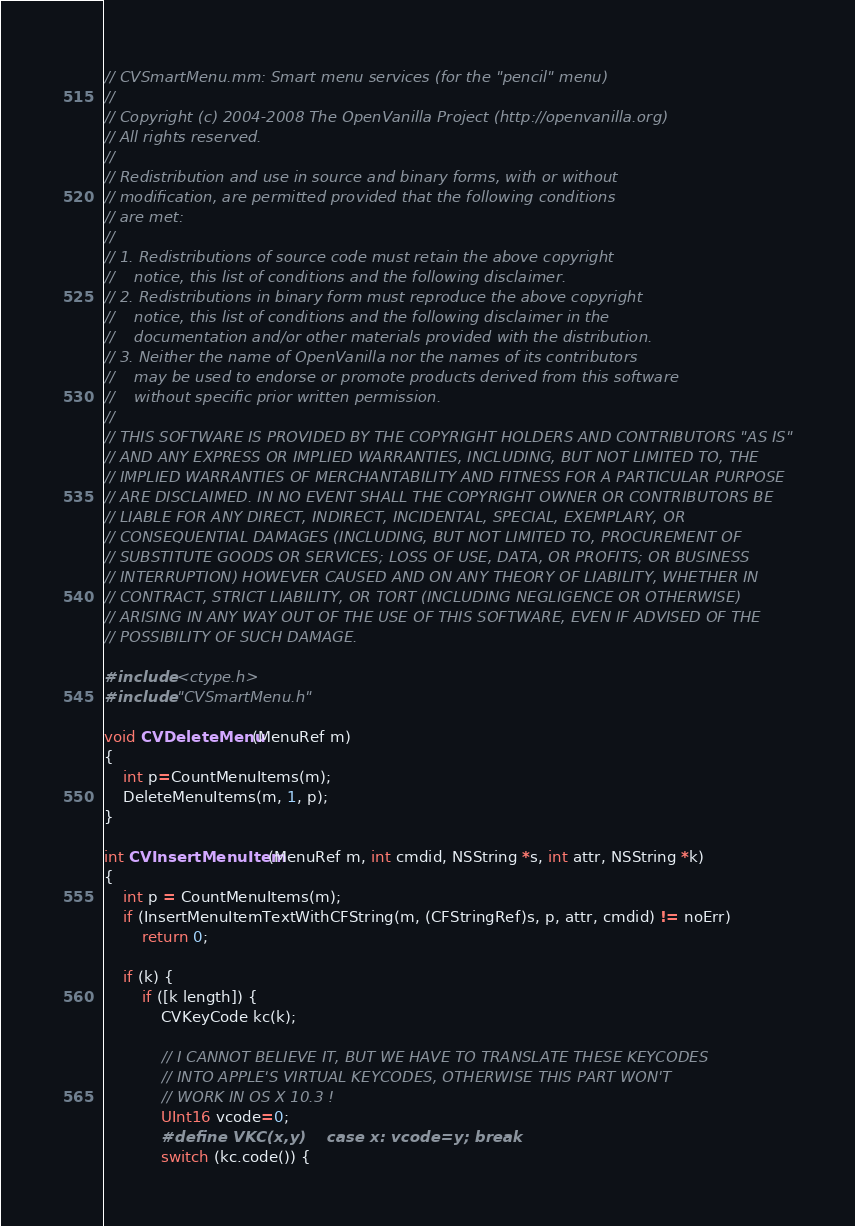Convert code to text. <code><loc_0><loc_0><loc_500><loc_500><_ObjectiveC_>// CVSmartMenu.mm: Smart menu services (for the "pencil" menu)
//
// Copyright (c) 2004-2008 The OpenVanilla Project (http://openvanilla.org)
// All rights reserved.
// 
// Redistribution and use in source and binary forms, with or without
// modification, are permitted provided that the following conditions
// are met:
// 
// 1. Redistributions of source code must retain the above copyright
//    notice, this list of conditions and the following disclaimer.
// 2. Redistributions in binary form must reproduce the above copyright
//    notice, this list of conditions and the following disclaimer in the
//    documentation and/or other materials provided with the distribution.
// 3. Neither the name of OpenVanilla nor the names of its contributors
//    may be used to endorse or promote products derived from this software
//    without specific prior written permission.
// 
// THIS SOFTWARE IS PROVIDED BY THE COPYRIGHT HOLDERS AND CONTRIBUTORS "AS IS"
// AND ANY EXPRESS OR IMPLIED WARRANTIES, INCLUDING, BUT NOT LIMITED TO, THE
// IMPLIED WARRANTIES OF MERCHANTABILITY AND FITNESS FOR A PARTICULAR PURPOSE
// ARE DISCLAIMED. IN NO EVENT SHALL THE COPYRIGHT OWNER OR CONTRIBUTORS BE
// LIABLE FOR ANY DIRECT, INDIRECT, INCIDENTAL, SPECIAL, EXEMPLARY, OR
// CONSEQUENTIAL DAMAGES (INCLUDING, BUT NOT LIMITED TO, PROCUREMENT OF
// SUBSTITUTE GOODS OR SERVICES; LOSS OF USE, DATA, OR PROFITS; OR BUSINESS
// INTERRUPTION) HOWEVER CAUSED AND ON ANY THEORY OF LIABILITY, WHETHER IN
// CONTRACT, STRICT LIABILITY, OR TORT (INCLUDING NEGLIGENCE OR OTHERWISE)
// ARISING IN ANY WAY OUT OF THE USE OF THIS SOFTWARE, EVEN IF ADVISED OF THE
// POSSIBILITY OF SUCH DAMAGE.

#include <ctype.h>
#include "CVSmartMenu.h"

void CVDeleteMenu(MenuRef m)
{
	int p=CountMenuItems(m);
	DeleteMenuItems(m, 1, p);
}

int CVInsertMenuItem(MenuRef m, int cmdid, NSString *s, int attr, NSString *k)
{
    int p = CountMenuItems(m);
    if (InsertMenuItemTextWithCFString(m, (CFStringRef)s, p, attr, cmdid) != noErr)
		return 0;
	
	if (k) {
        if ([k length]) {
            CVKeyCode kc(k);
            
            // I CANNOT BELIEVE IT, BUT WE HAVE TO TRANSLATE THESE KEYCODES
            // INTO APPLE'S VIRTUAL KEYCODES, OTHERWISE THIS PART WON'T
            // WORK IN OS X 10.3 !
            UInt16 vcode=0;
            #define VKC(x,y)    case x: vcode=y; break
            switch (kc.code()) {</code> 